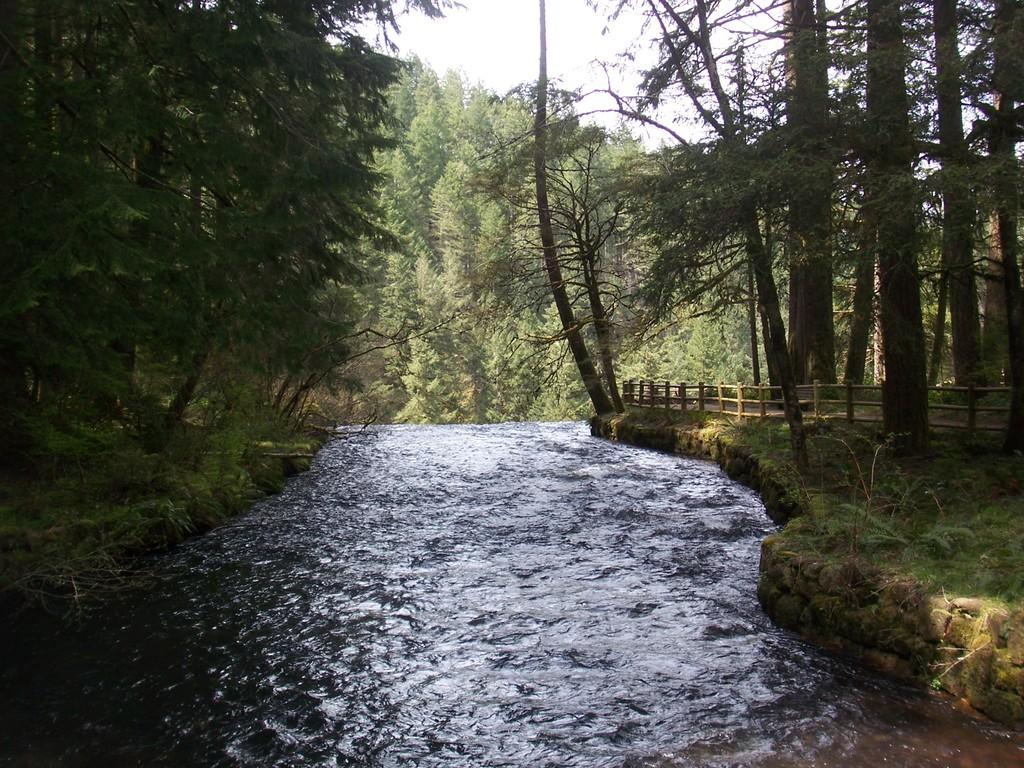What is the primary element visible in the image? There is water in the image. What type of structure can be seen in the image? There is a fence in the image. What type of vegetation is present in the image? There are plants and trees in the image. What can be seen in the background of the image? The sky is visible in the background of the image. What month is it in the image? The month cannot be determined from the image, as there is no information about the time of year or specific date. How many cattle are visible in the image? There are no cattle present in the image. 